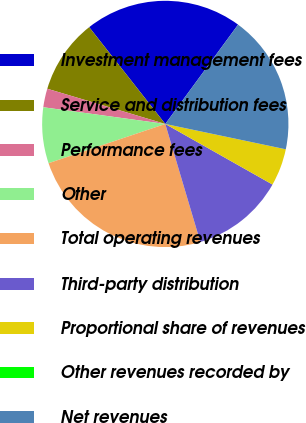Convert chart. <chart><loc_0><loc_0><loc_500><loc_500><pie_chart><fcel>Investment management fees<fcel>Service and distribution fees<fcel>Performance fees<fcel>Other<fcel>Total operating revenues<fcel>Third-party distribution<fcel>Proportional share of revenues<fcel>Other revenues recorded by<fcel>Net revenues<nl><fcel>20.67%<fcel>9.78%<fcel>2.45%<fcel>7.33%<fcel>24.43%<fcel>12.22%<fcel>4.89%<fcel>0.0%<fcel>18.23%<nl></chart> 